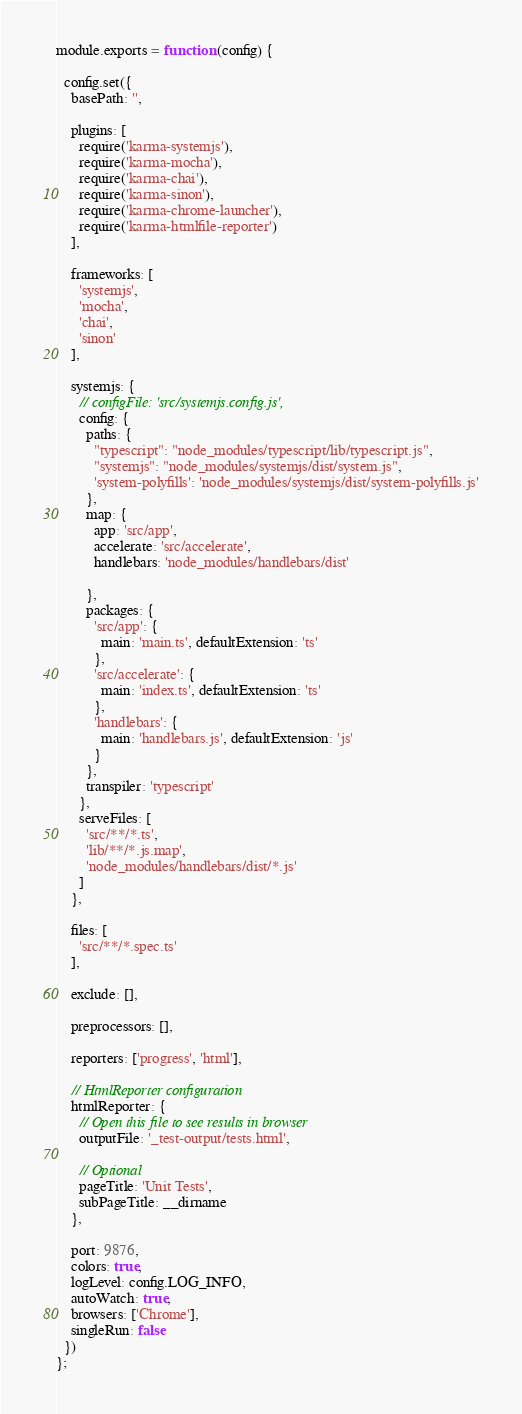<code> <loc_0><loc_0><loc_500><loc_500><_JavaScript_>module.exports = function (config) {

  config.set({
    basePath: '',

    plugins: [
      require('karma-systemjs'),
      require('karma-mocha'),
      require('karma-chai'),
      require('karma-sinon'),
      require('karma-chrome-launcher'),
      require('karma-htmlfile-reporter')
    ],

    frameworks: [
      'systemjs',
      'mocha',
      'chai',
      'sinon'
    ],

    systemjs: {
      // configFile: 'src/systemjs.config.js',
      config: {
        paths: {
          "typescript": "node_modules/typescript/lib/typescript.js",
          "systemjs": "node_modules/systemjs/dist/system.js",
          'system-polyfills': 'node_modules/systemjs/dist/system-polyfills.js'
        },
        map: {
          app: 'src/app',
          accelerate: 'src/accelerate',
          handlebars: 'node_modules/handlebars/dist'

        },
        packages: {
          'src/app': {
            main: 'main.ts', defaultExtension: 'ts'
          },
          'src/accelerate': {
            main: 'index.ts', defaultExtension: 'ts'
          },
          'handlebars': {
            main: 'handlebars.js', defaultExtension: 'js'
          }
        },
        transpiler: 'typescript'
      },
      serveFiles: [
        'src/**/*.ts',
        'lib/**/*.js.map',
        'node_modules/handlebars/dist/*.js'
      ]
    },

    files: [
      'src/**/*.spec.ts'
    ],

    exclude: [],

    preprocessors: [],

    reporters: ['progress', 'html'],

    // HtmlReporter configuration
    htmlReporter: {
      // Open this file to see results in browser
      outputFile: '_test-output/tests.html',

      // Optional
      pageTitle: 'Unit Tests',
      subPageTitle: __dirname
    },

    port: 9876,
    colors: true,
    logLevel: config.LOG_INFO,
    autoWatch: true,
    browsers: ['Chrome'],
    singleRun: false
  })
};
</code> 